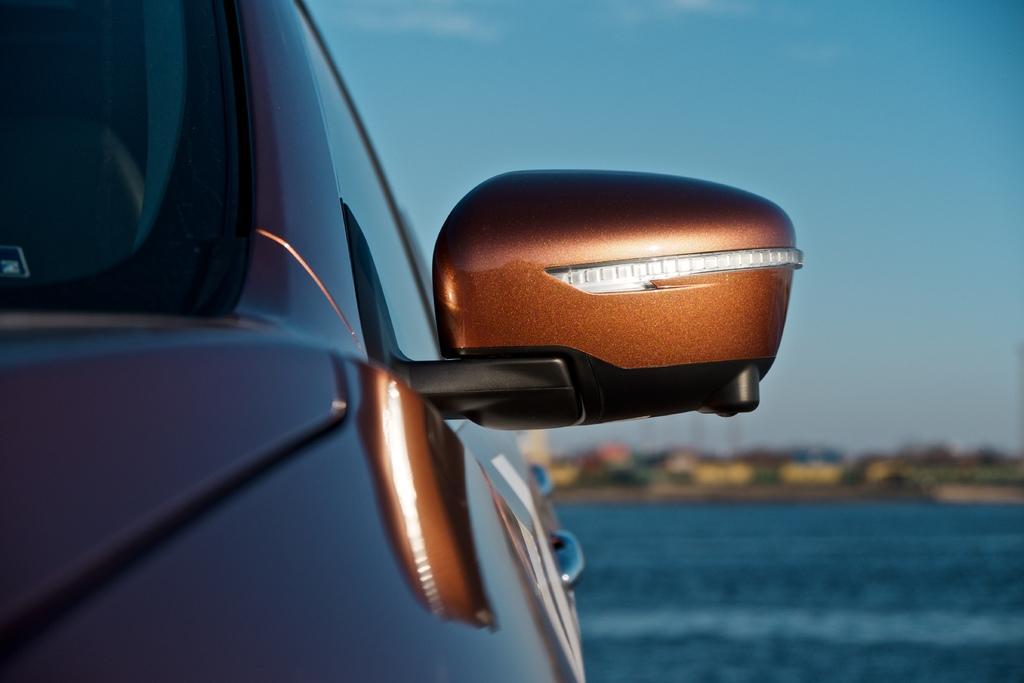How would you summarize this image in a sentence or two? On the left side there is a car where we can see the side mirror and side face of the car. In the background the image is blur but we can see a road,trees and sky. 